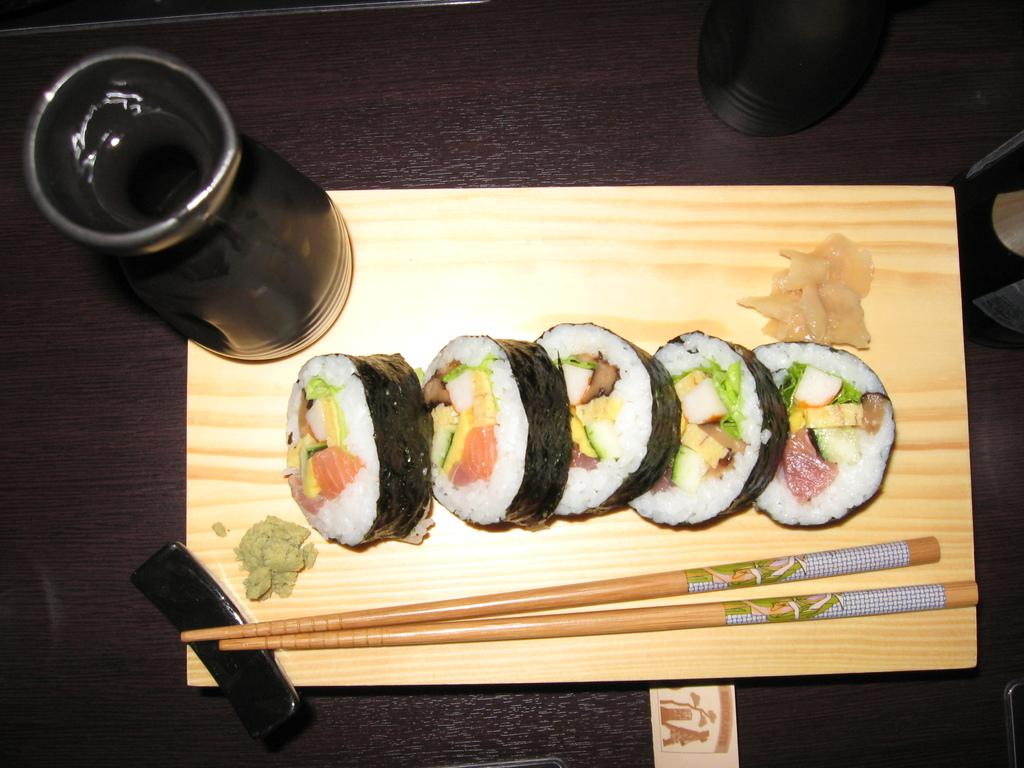What type of food can be seen in the image? The image contains food, but the specific type cannot be determined from the provided facts. What utensil is present in the image? Chopsticks are visible in the image. What is on the table in the image? There is a glass on the table in the image. What type of ship is visible in the image? There is no ship present in the image. How many parcels are on the table in the image? There is no parcel present in the image. 